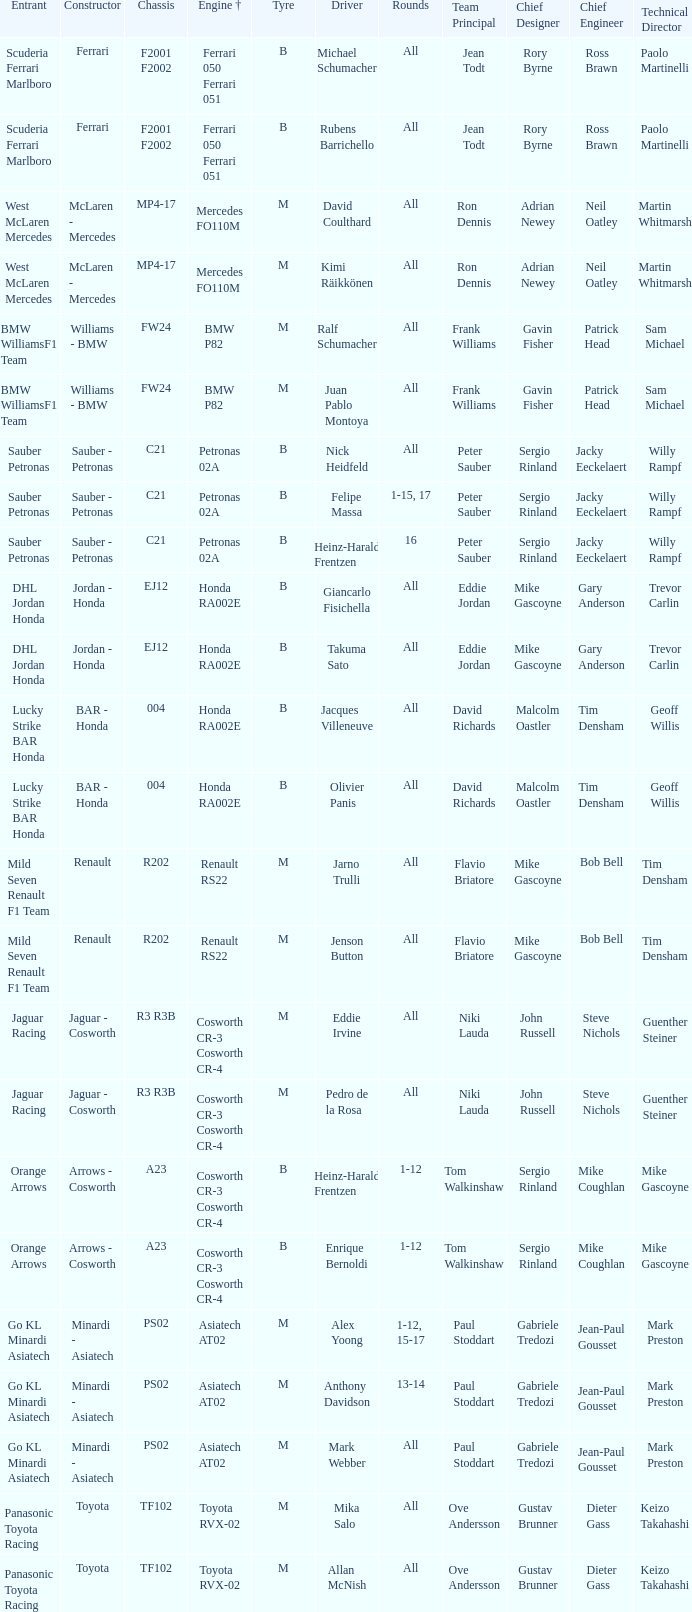Who is the driver when the engine is mercedes fo110m? David Coulthard, Kimi Räikkönen. 